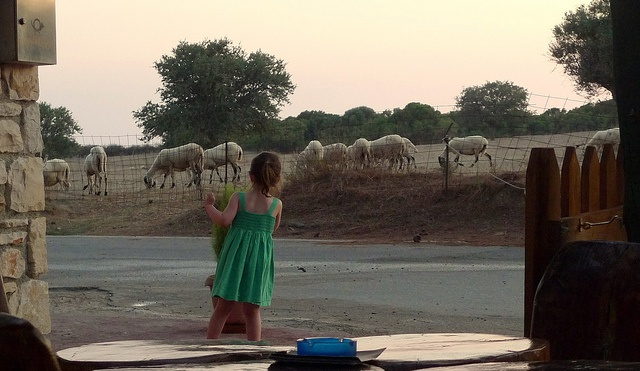Describe the objects in this image and their specific colors. I can see chair in black and gray tones, people in black, darkgreen, and maroon tones, chair in black and gray tones, sheep in black and gray tones, and sheep in black and gray tones in this image. 